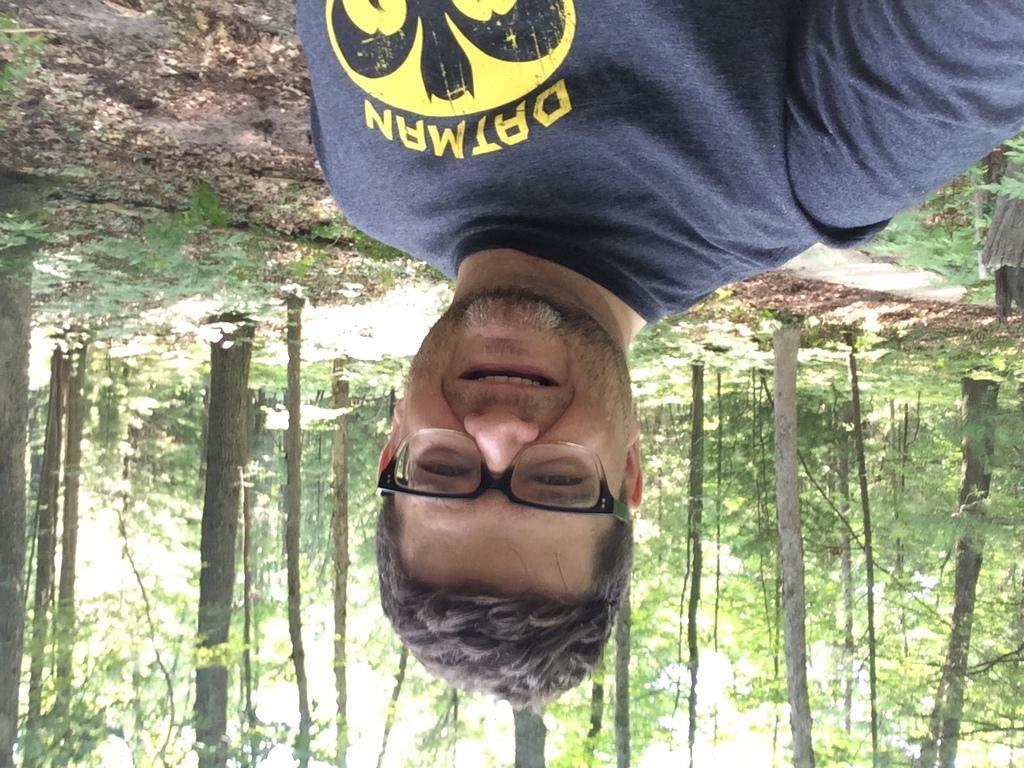Can you describe this image briefly? In this image I can see a man is smiling. The man is wearing a t-shirt and spectacles. In the background I can see trees. 